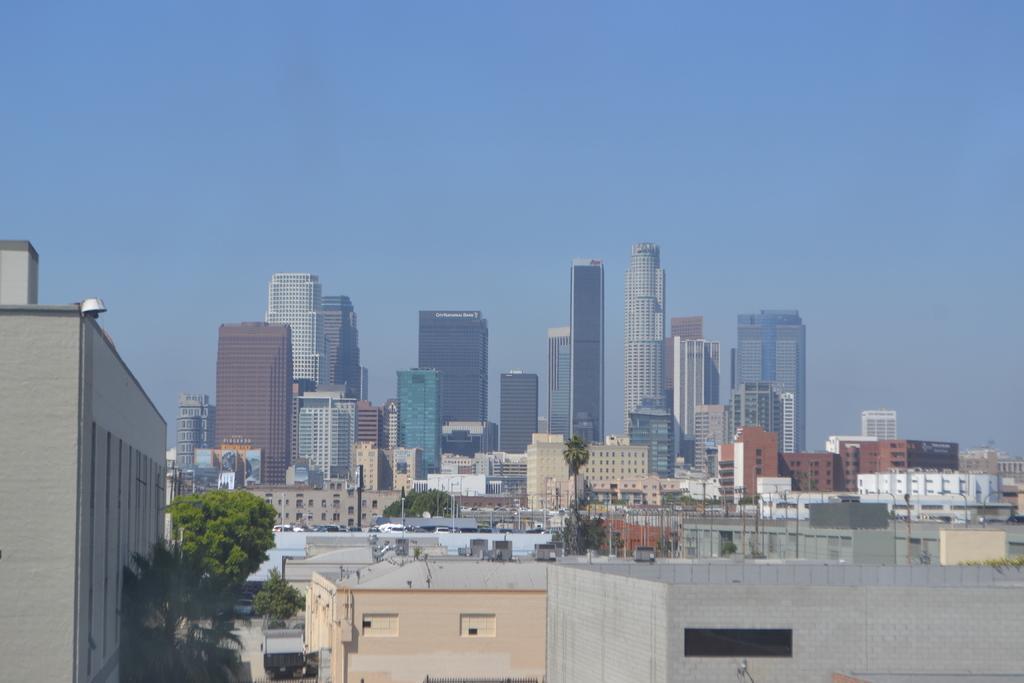In one or two sentences, can you explain what this image depicts? In this image we can see many buildings and also some trees. We can also see the vehicles, poles. Sky is also visible. 